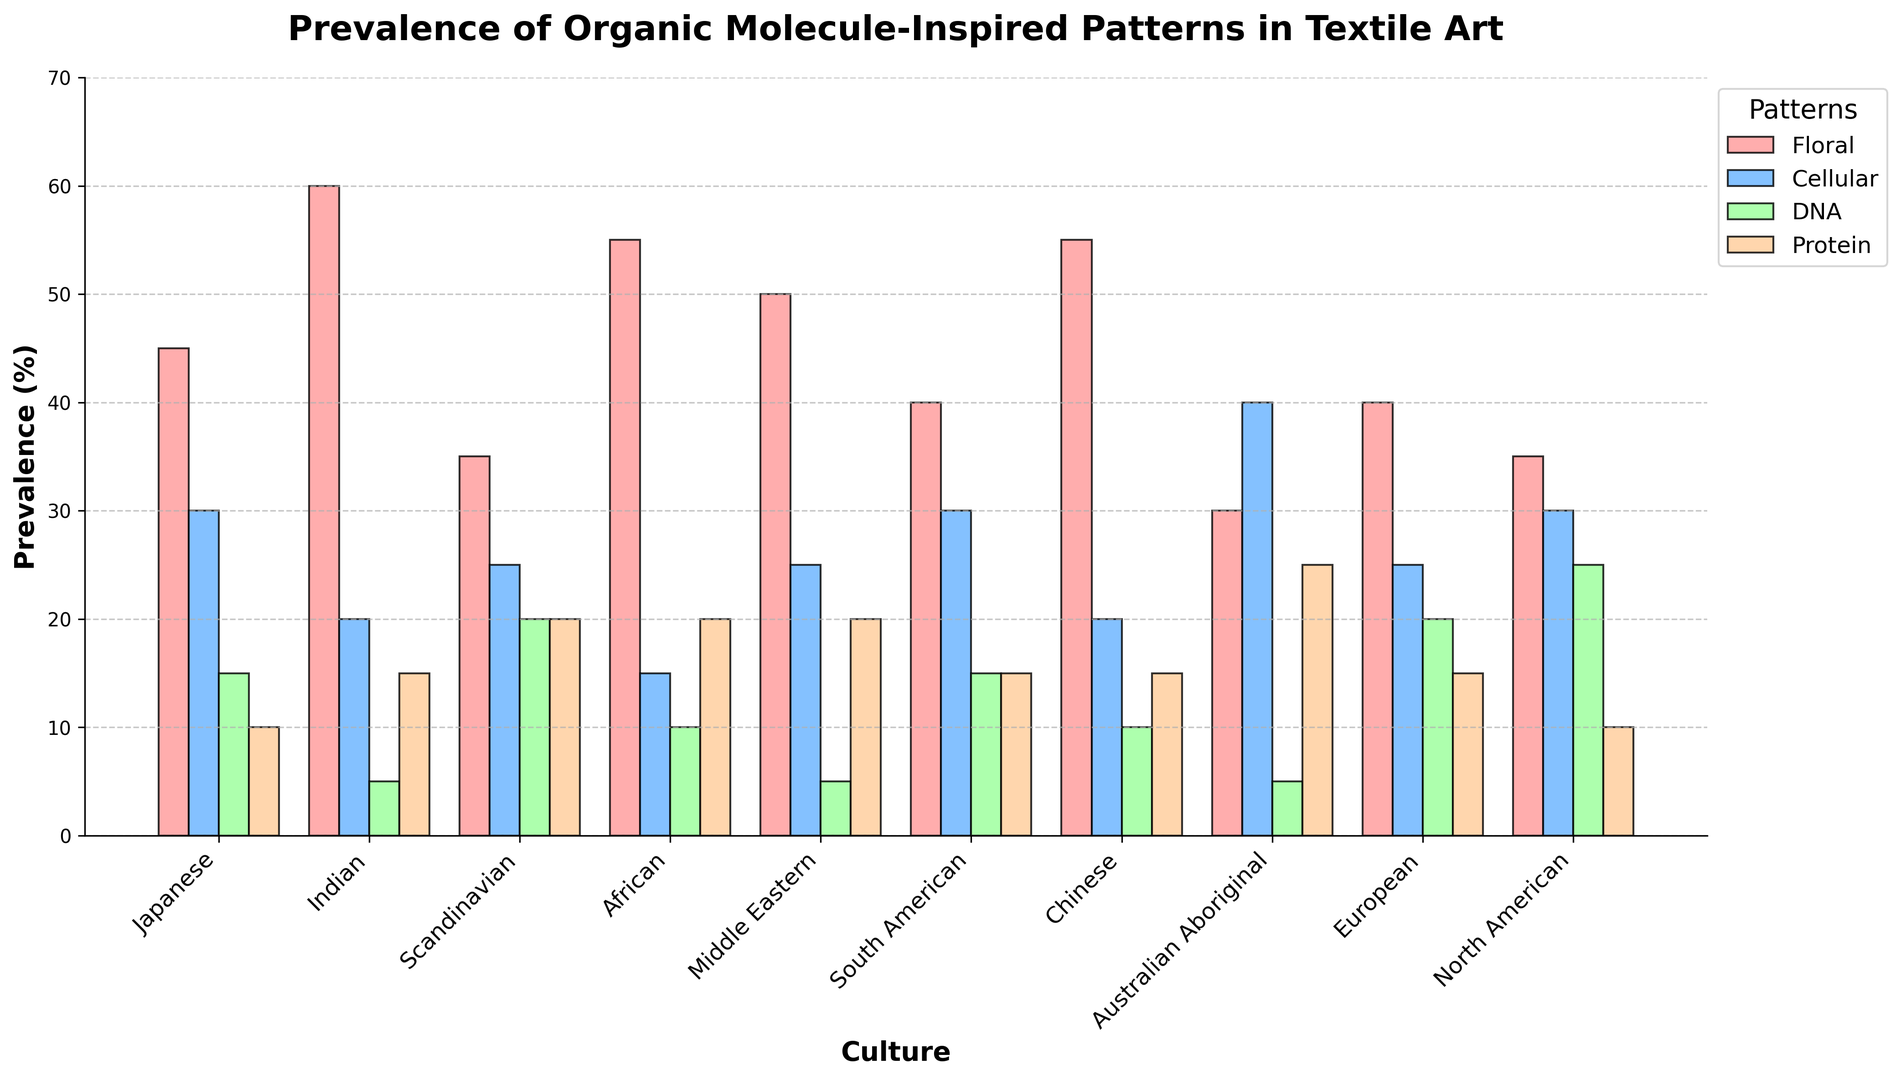What's the most prevalent pattern in Japanese textile art? By looking at the heights of the bars for the Japanese culture group, we see that the Floral pattern has the highest bar at 45%.
Answer: Floral Which culture has the least prevalence of DNA patterns? Observe the heights of the DNA pattern bars across all cultures. The Indian and Middle Eastern cultures both have the lowest DNA prevalence at 5%.
Answer: Indian and Middle Eastern What is the average prevalence of Cellular patterns in African and North American textile art? Identify the Cellular pattern bars for African (15%) and North American (30%). The average is (15 + 30) / 2 = 22.5%.
Answer: 22.5% How does the Protein pattern prevalence in South American textile art compare to that in Australian Aboriginal textile art? Look at the Protein pattern bars for South American (15%) and Australian Aboriginal (25%) cultures. The Protein pattern is more prevalent by 10% in Australian Aboriginal textile art.
Answer: Australian Aboriginal has 10% more Which pattern is equally prevalent in both Indian and Middle Eastern textile art? Compare the bar heights for each pattern between Indian and Middle Eastern cultures, noting that both have the same height bar for the DNA pattern at 5%.
Answer: DNA Which culture shows the greatest prevalence difference between Floral and Protein patterns? Calculate the difference between the heights of the Floral and Protein bars for each culture. The Indian culture has the largest difference: 60% (Floral) - 15% (Protein) = 45%.
Answer: Indian What is the sum of the percentages for Floral patterns in Japanese, Indian, and African textile art? Sum the Floral pattern percentages: Japanese (45%) + Indian (60%) + African (55%) = 160%.
Answer: 160% In which culture is the ratio of the prevalence of Protein patterns to DNA patterns the highest? Calculate the ratio of Protein to DNA prevalence for each culture. For African culture, it's 20% / 10% = 2, which is the highest ratio.
Answer: African How do the heights of the Cellular pattern bars differ between Scandinavian and Chinese cultures? The Scandinavian Cellular pattern bar is at 25%, and the Chinese Cellular pattern bar is at 20%. The difference is 5%.
Answer: 5% What is the median prevalence value for the Floral pattern across all cultures? List all Floral pattern values: 45, 60, 35, 55, 50, 40, 55, 30, 40, 35. The median value, when ordered, is (40 + 45) / 2 = 42.5%.
Answer: 42.5% 